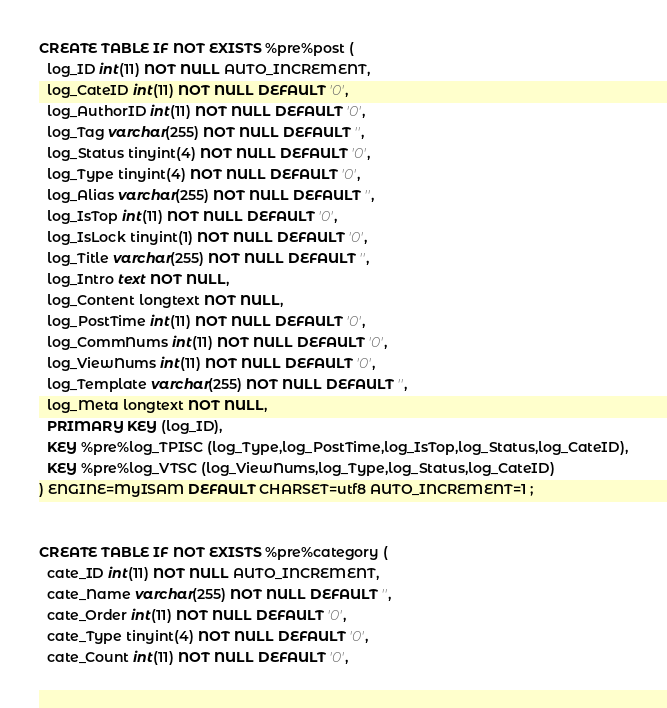Convert code to text. <code><loc_0><loc_0><loc_500><loc_500><_SQL_>CREATE TABLE IF NOT EXISTS %pre%post (
  log_ID int(11) NOT NULL AUTO_INCREMENT,
  log_CateID int(11) NOT NULL DEFAULT '0',
  log_AuthorID int(11) NOT NULL DEFAULT '0',
  log_Tag varchar(255) NOT NULL DEFAULT '',
  log_Status tinyint(4) NOT NULL DEFAULT '0',
  log_Type tinyint(4) NOT NULL DEFAULT '0',
  log_Alias varchar(255) NOT NULL DEFAULT '',
  log_IsTop int(11) NOT NULL DEFAULT '0',
  log_IsLock tinyint(1) NOT NULL DEFAULT '0',
  log_Title varchar(255) NOT NULL DEFAULT '',
  log_Intro text NOT NULL,
  log_Content longtext NOT NULL,
  log_PostTime int(11) NOT NULL DEFAULT '0',
  log_CommNums int(11) NOT NULL DEFAULT '0',
  log_ViewNums int(11) NOT NULL DEFAULT '0',
  log_Template varchar(255) NOT NULL DEFAULT '',
  log_Meta longtext NOT NULL,
  PRIMARY KEY (log_ID),
  KEY %pre%log_TPISC (log_Type,log_PostTime,log_IsTop,log_Status,log_CateID),
  KEY %pre%log_VTSC (log_ViewNums,log_Type,log_Status,log_CateID)
) ENGINE=MyISAM DEFAULT CHARSET=utf8 AUTO_INCREMENT=1 ;


CREATE TABLE IF NOT EXISTS %pre%category (
  cate_ID int(11) NOT NULL AUTO_INCREMENT,
  cate_Name varchar(255) NOT NULL DEFAULT '',
  cate_Order int(11) NOT NULL DEFAULT '0',
  cate_Type tinyint(4) NOT NULL DEFAULT '0',
  cate_Count int(11) NOT NULL DEFAULT '0',</code> 